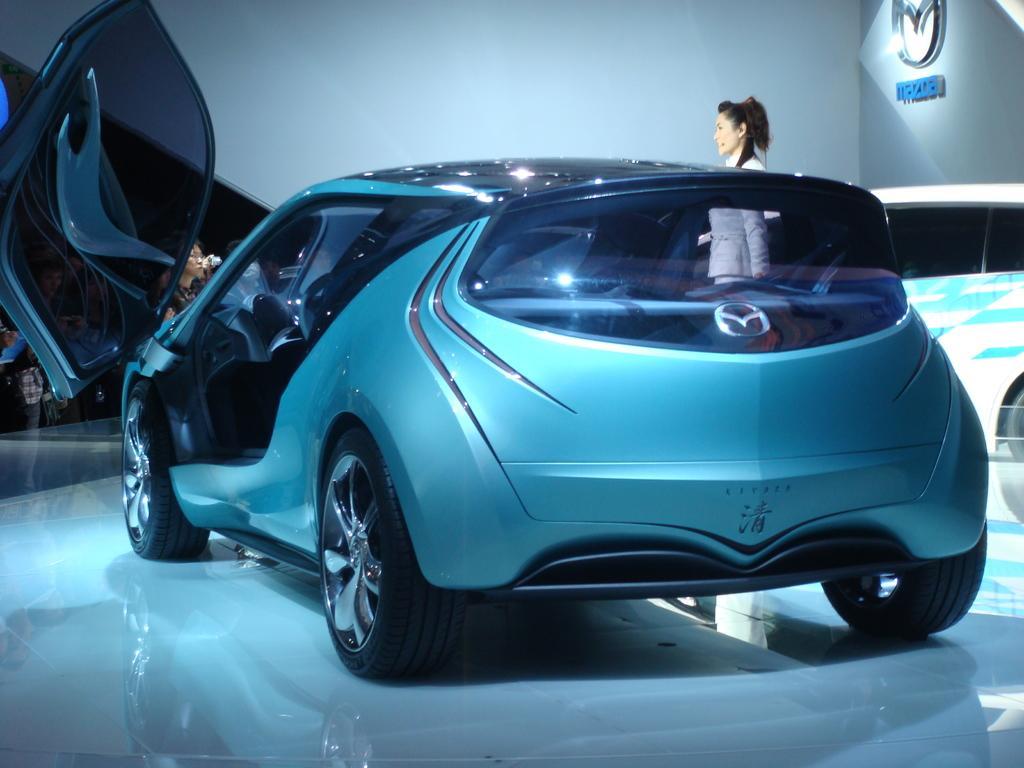Please provide a concise description of this image. In this image there is a car, beside the car there is a woman standing, beside the woman there is another car, in front of the car there is another person, in front of the car there is a logo on the wall. 